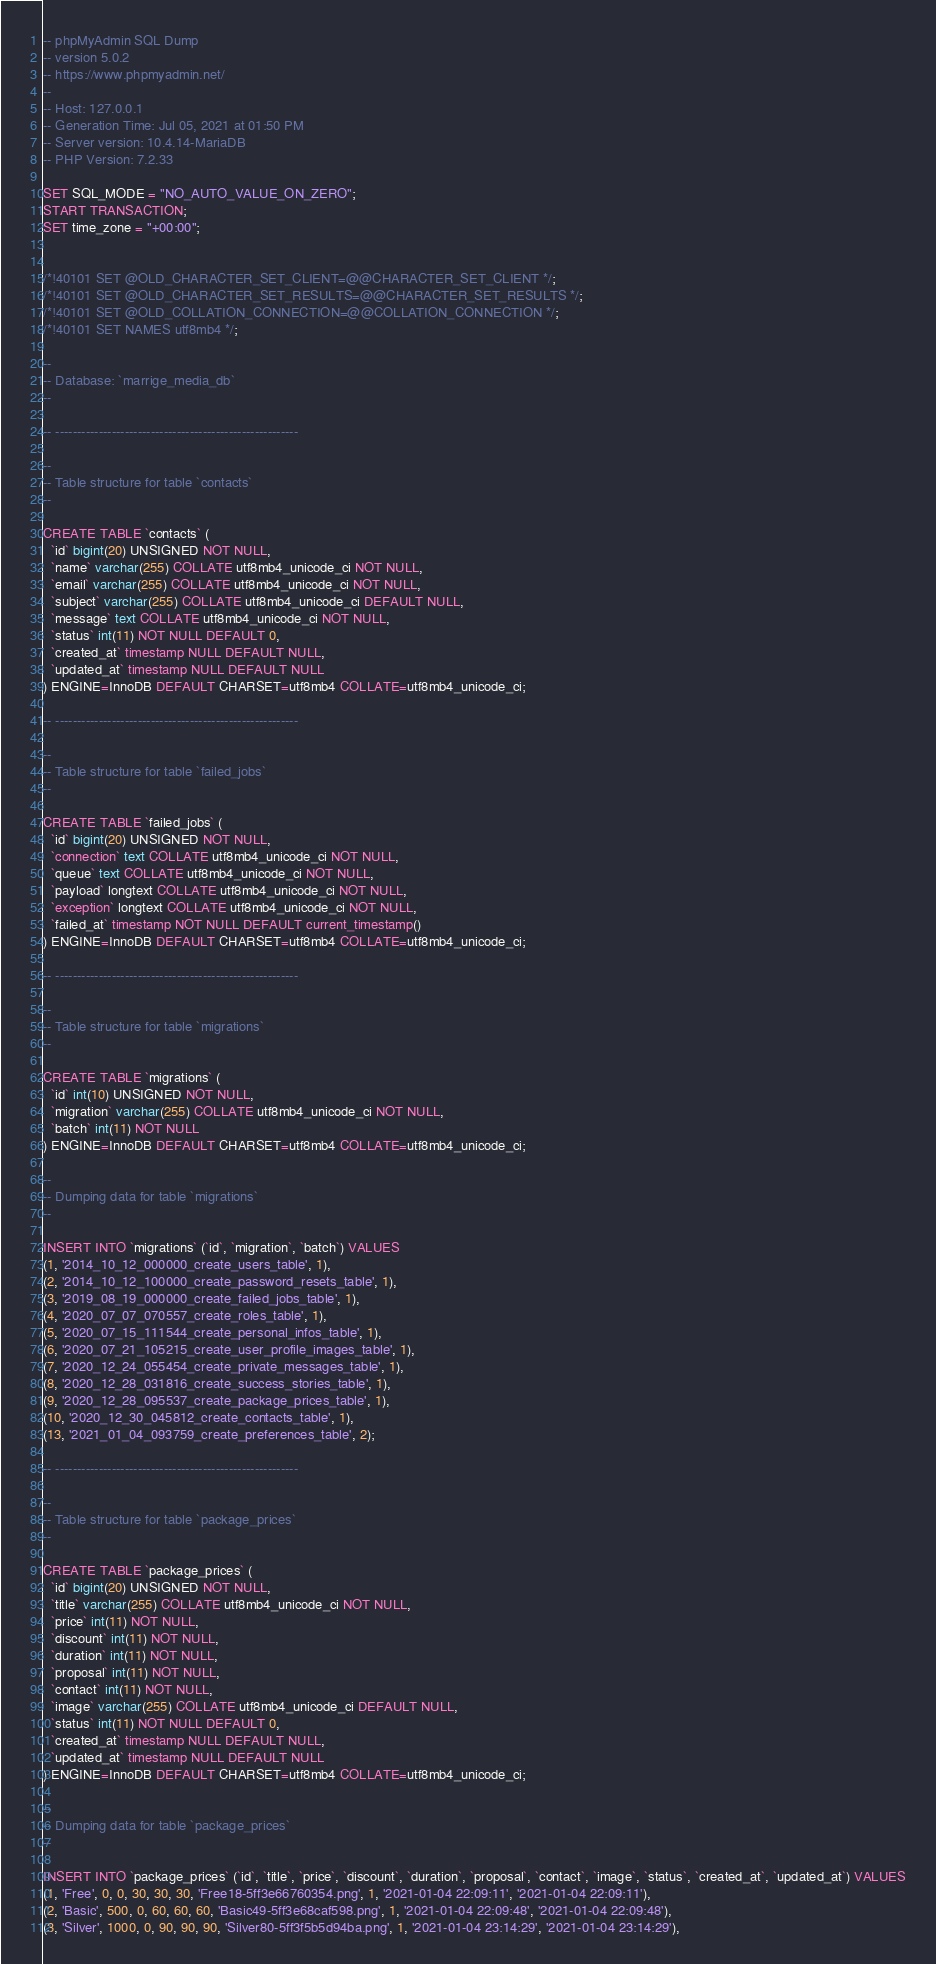Convert code to text. <code><loc_0><loc_0><loc_500><loc_500><_SQL_>-- phpMyAdmin SQL Dump
-- version 5.0.2
-- https://www.phpmyadmin.net/
--
-- Host: 127.0.0.1
-- Generation Time: Jul 05, 2021 at 01:50 PM
-- Server version: 10.4.14-MariaDB
-- PHP Version: 7.2.33

SET SQL_MODE = "NO_AUTO_VALUE_ON_ZERO";
START TRANSACTION;
SET time_zone = "+00:00";


/*!40101 SET @OLD_CHARACTER_SET_CLIENT=@@CHARACTER_SET_CLIENT */;
/*!40101 SET @OLD_CHARACTER_SET_RESULTS=@@CHARACTER_SET_RESULTS */;
/*!40101 SET @OLD_COLLATION_CONNECTION=@@COLLATION_CONNECTION */;
/*!40101 SET NAMES utf8mb4 */;

--
-- Database: `marrige_media_db`
--

-- --------------------------------------------------------

--
-- Table structure for table `contacts`
--

CREATE TABLE `contacts` (
  `id` bigint(20) UNSIGNED NOT NULL,
  `name` varchar(255) COLLATE utf8mb4_unicode_ci NOT NULL,
  `email` varchar(255) COLLATE utf8mb4_unicode_ci NOT NULL,
  `subject` varchar(255) COLLATE utf8mb4_unicode_ci DEFAULT NULL,
  `message` text COLLATE utf8mb4_unicode_ci NOT NULL,
  `status` int(11) NOT NULL DEFAULT 0,
  `created_at` timestamp NULL DEFAULT NULL,
  `updated_at` timestamp NULL DEFAULT NULL
) ENGINE=InnoDB DEFAULT CHARSET=utf8mb4 COLLATE=utf8mb4_unicode_ci;

-- --------------------------------------------------------

--
-- Table structure for table `failed_jobs`
--

CREATE TABLE `failed_jobs` (
  `id` bigint(20) UNSIGNED NOT NULL,
  `connection` text COLLATE utf8mb4_unicode_ci NOT NULL,
  `queue` text COLLATE utf8mb4_unicode_ci NOT NULL,
  `payload` longtext COLLATE utf8mb4_unicode_ci NOT NULL,
  `exception` longtext COLLATE utf8mb4_unicode_ci NOT NULL,
  `failed_at` timestamp NOT NULL DEFAULT current_timestamp()
) ENGINE=InnoDB DEFAULT CHARSET=utf8mb4 COLLATE=utf8mb4_unicode_ci;

-- --------------------------------------------------------

--
-- Table structure for table `migrations`
--

CREATE TABLE `migrations` (
  `id` int(10) UNSIGNED NOT NULL,
  `migration` varchar(255) COLLATE utf8mb4_unicode_ci NOT NULL,
  `batch` int(11) NOT NULL
) ENGINE=InnoDB DEFAULT CHARSET=utf8mb4 COLLATE=utf8mb4_unicode_ci;

--
-- Dumping data for table `migrations`
--

INSERT INTO `migrations` (`id`, `migration`, `batch`) VALUES
(1, '2014_10_12_000000_create_users_table', 1),
(2, '2014_10_12_100000_create_password_resets_table', 1),
(3, '2019_08_19_000000_create_failed_jobs_table', 1),
(4, '2020_07_07_070557_create_roles_table', 1),
(5, '2020_07_15_111544_create_personal_infos_table', 1),
(6, '2020_07_21_105215_create_user_profile_images_table', 1),
(7, '2020_12_24_055454_create_private_messages_table', 1),
(8, '2020_12_28_031816_create_success_stories_table', 1),
(9, '2020_12_28_095537_create_package_prices_table', 1),
(10, '2020_12_30_045812_create_contacts_table', 1),
(13, '2021_01_04_093759_create_preferences_table', 2);

-- --------------------------------------------------------

--
-- Table structure for table `package_prices`
--

CREATE TABLE `package_prices` (
  `id` bigint(20) UNSIGNED NOT NULL,
  `title` varchar(255) COLLATE utf8mb4_unicode_ci NOT NULL,
  `price` int(11) NOT NULL,
  `discount` int(11) NOT NULL,
  `duration` int(11) NOT NULL,
  `proposal` int(11) NOT NULL,
  `contact` int(11) NOT NULL,
  `image` varchar(255) COLLATE utf8mb4_unicode_ci DEFAULT NULL,
  `status` int(11) NOT NULL DEFAULT 0,
  `created_at` timestamp NULL DEFAULT NULL,
  `updated_at` timestamp NULL DEFAULT NULL
) ENGINE=InnoDB DEFAULT CHARSET=utf8mb4 COLLATE=utf8mb4_unicode_ci;

--
-- Dumping data for table `package_prices`
--

INSERT INTO `package_prices` (`id`, `title`, `price`, `discount`, `duration`, `proposal`, `contact`, `image`, `status`, `created_at`, `updated_at`) VALUES
(1, 'Free', 0, 0, 30, 30, 30, 'Free18-5ff3e66760354.png', 1, '2021-01-04 22:09:11', '2021-01-04 22:09:11'),
(2, 'Basic', 500, 0, 60, 60, 60, 'Basic49-5ff3e68caf598.png', 1, '2021-01-04 22:09:48', '2021-01-04 22:09:48'),
(3, 'Silver', 1000, 0, 90, 90, 90, 'Silver80-5ff3f5b5d94ba.png', 1, '2021-01-04 23:14:29', '2021-01-04 23:14:29'),</code> 